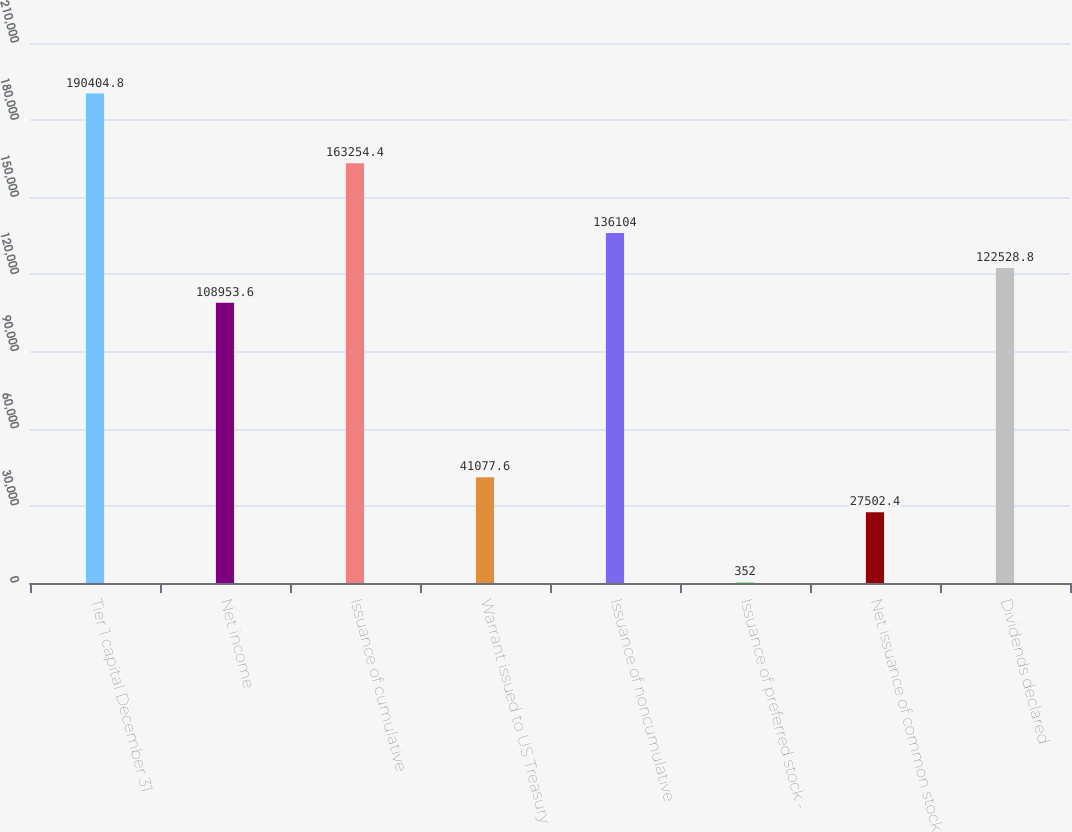Convert chart to OTSL. <chart><loc_0><loc_0><loc_500><loc_500><bar_chart><fcel>Tier 1 capital December 31<fcel>Net income<fcel>Issuance of cumulative<fcel>Warrant issued to US Treasury<fcel>Issuance of noncumulative<fcel>Issuance of preferred stock -<fcel>Net issuance of common stock<fcel>Dividends declared<nl><fcel>190405<fcel>108954<fcel>163254<fcel>41077.6<fcel>136104<fcel>352<fcel>27502.4<fcel>122529<nl></chart> 